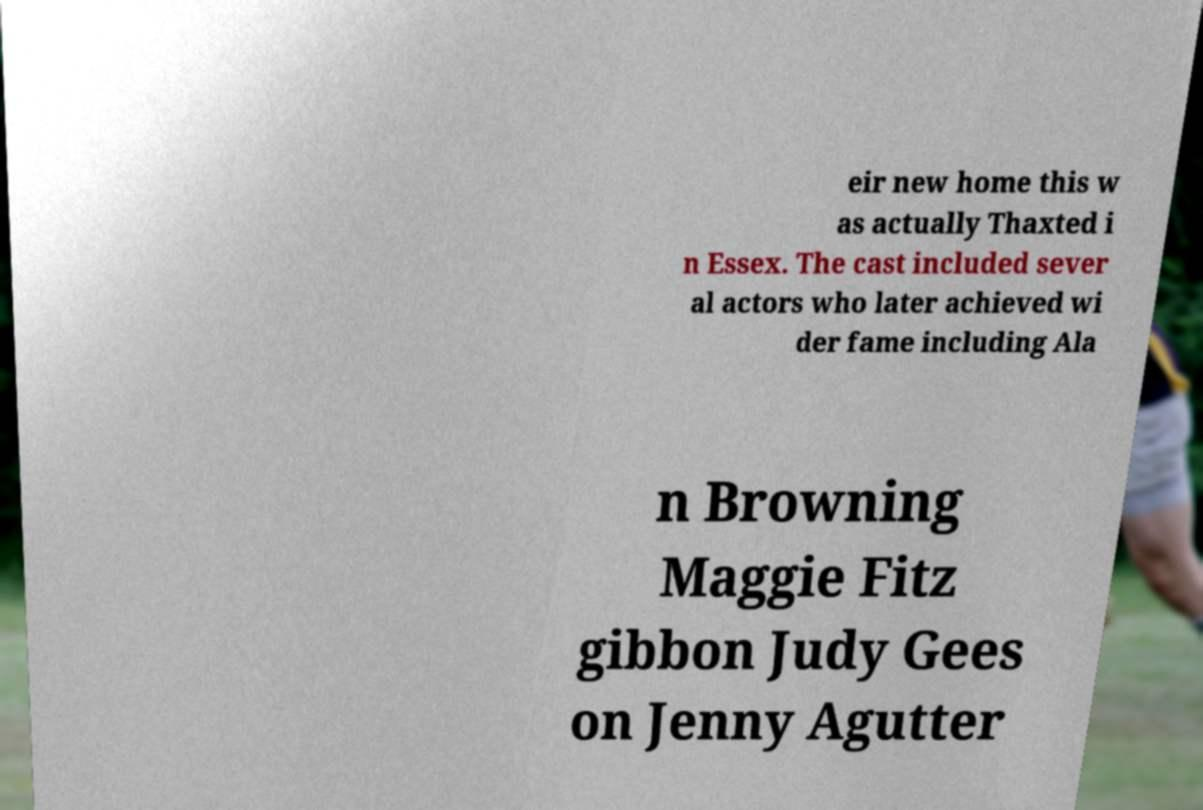Please read and relay the text visible in this image. What does it say? eir new home this w as actually Thaxted i n Essex. The cast included sever al actors who later achieved wi der fame including Ala n Browning Maggie Fitz gibbon Judy Gees on Jenny Agutter 